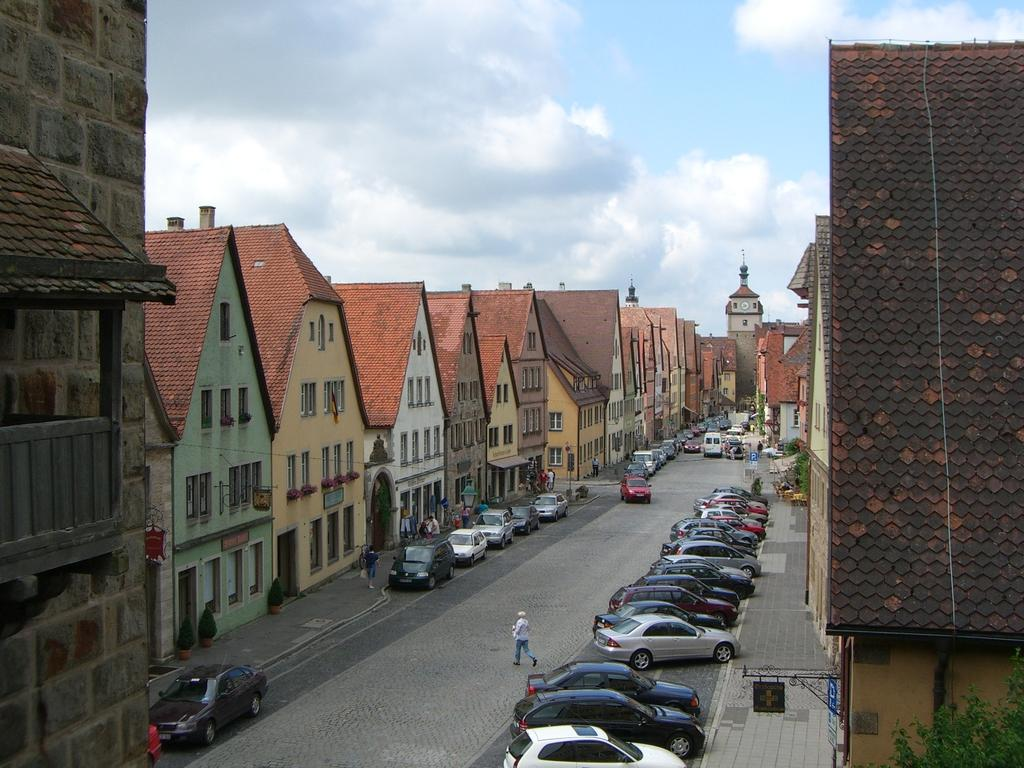Who or what can be seen in the image? There are people in the image. What else is visible in the image besides the people? There are vehicles on the road and buildings on either side of the road in the image. What can be seen in the sky in the image? There are clouds in the sky in the image. Where is the throne located in the image? There is no throne present in the image. What type of cough can be heard from the people in the image? The image is a still picture, so there is no sound or coughing present. 